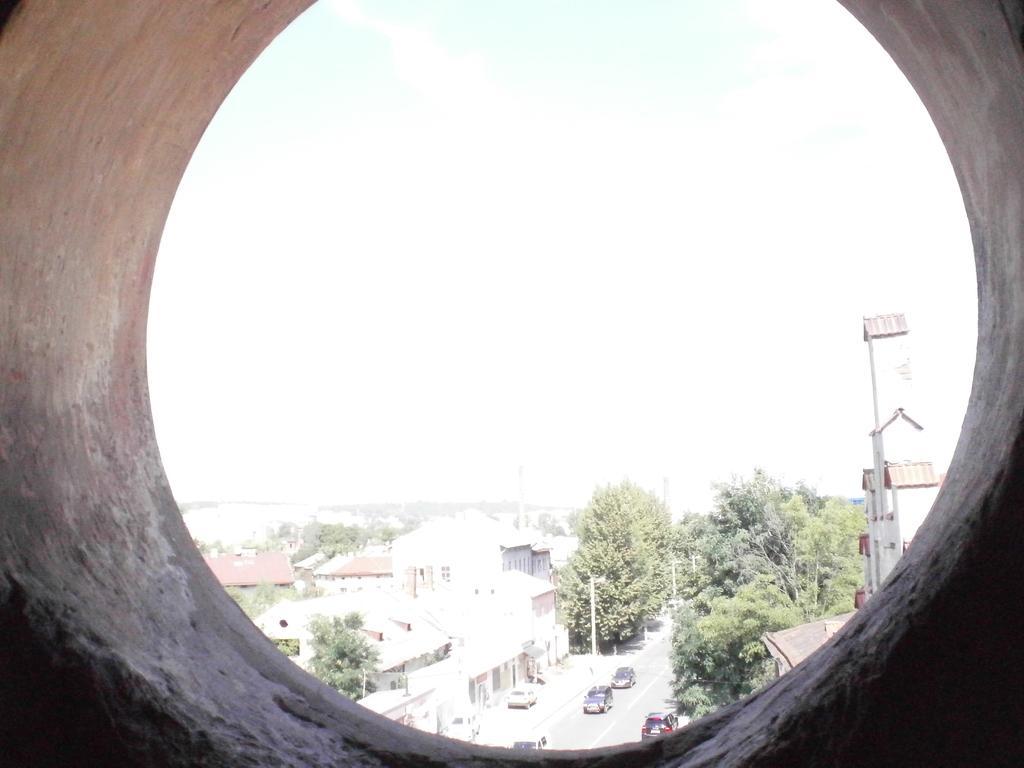Describe this image in one or two sentences. In the picture it seems like there is a cement pipe the foreground, behind that there are houses, trees, roads, poles and vehicles. 